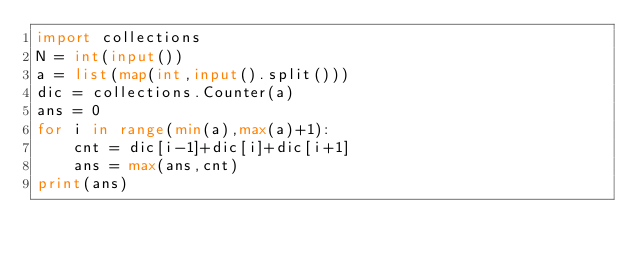Convert code to text. <code><loc_0><loc_0><loc_500><loc_500><_Python_>import collections
N = int(input())
a = list(map(int,input().split()))
dic = collections.Counter(a)
ans = 0
for i in range(min(a),max(a)+1):
    cnt = dic[i-1]+dic[i]+dic[i+1]
    ans = max(ans,cnt)
print(ans)</code> 